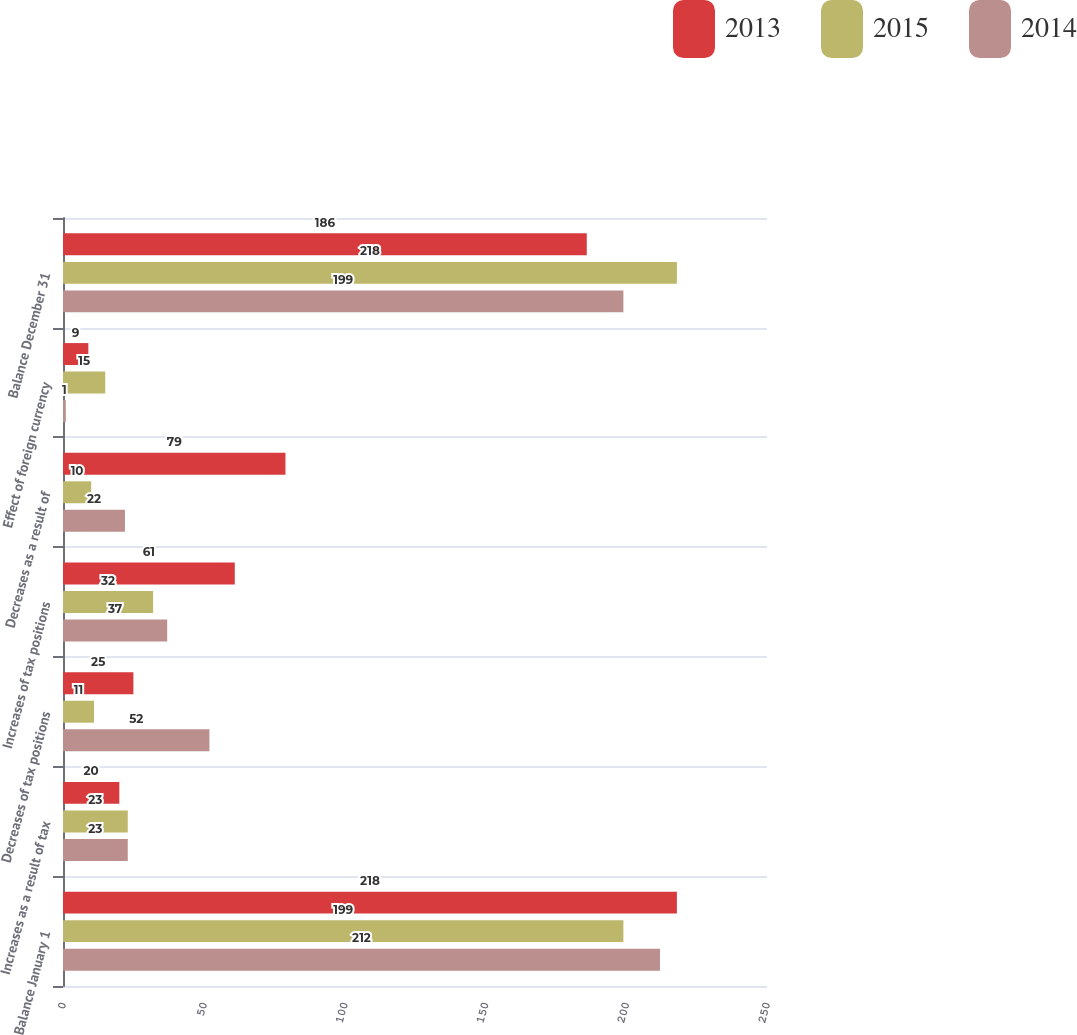Convert chart to OTSL. <chart><loc_0><loc_0><loc_500><loc_500><stacked_bar_chart><ecel><fcel>Balance January 1<fcel>Increases as a result of tax<fcel>Decreases of tax positions<fcel>Increases of tax positions<fcel>Decreases as a result of<fcel>Effect of foreign currency<fcel>Balance December 31<nl><fcel>2013<fcel>218<fcel>20<fcel>25<fcel>61<fcel>79<fcel>9<fcel>186<nl><fcel>2015<fcel>199<fcel>23<fcel>11<fcel>32<fcel>10<fcel>15<fcel>218<nl><fcel>2014<fcel>212<fcel>23<fcel>52<fcel>37<fcel>22<fcel>1<fcel>199<nl></chart> 